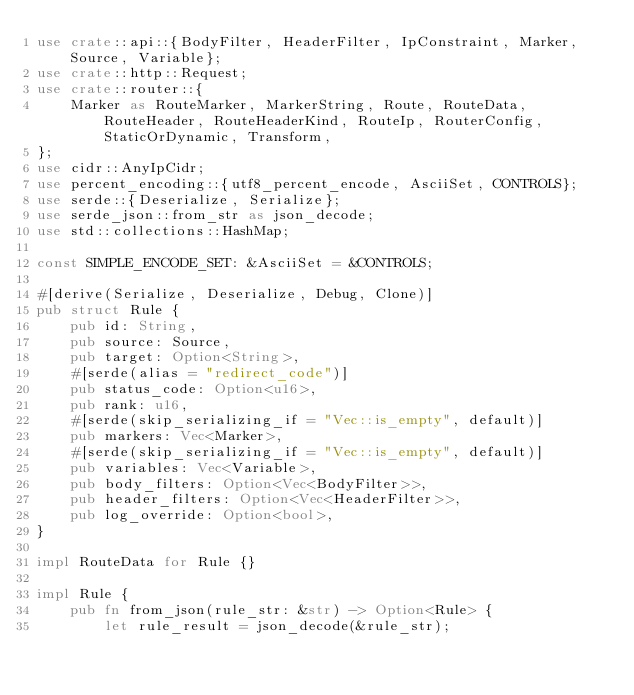<code> <loc_0><loc_0><loc_500><loc_500><_Rust_>use crate::api::{BodyFilter, HeaderFilter, IpConstraint, Marker, Source, Variable};
use crate::http::Request;
use crate::router::{
    Marker as RouteMarker, MarkerString, Route, RouteData, RouteHeader, RouteHeaderKind, RouteIp, RouterConfig, StaticOrDynamic, Transform,
};
use cidr::AnyIpCidr;
use percent_encoding::{utf8_percent_encode, AsciiSet, CONTROLS};
use serde::{Deserialize, Serialize};
use serde_json::from_str as json_decode;
use std::collections::HashMap;

const SIMPLE_ENCODE_SET: &AsciiSet = &CONTROLS;

#[derive(Serialize, Deserialize, Debug, Clone)]
pub struct Rule {
    pub id: String,
    pub source: Source,
    pub target: Option<String>,
    #[serde(alias = "redirect_code")]
    pub status_code: Option<u16>,
    pub rank: u16,
    #[serde(skip_serializing_if = "Vec::is_empty", default)]
    pub markers: Vec<Marker>,
    #[serde(skip_serializing_if = "Vec::is_empty", default)]
    pub variables: Vec<Variable>,
    pub body_filters: Option<Vec<BodyFilter>>,
    pub header_filters: Option<Vec<HeaderFilter>>,
    pub log_override: Option<bool>,
}

impl RouteData for Rule {}

impl Rule {
    pub fn from_json(rule_str: &str) -> Option<Rule> {
        let rule_result = json_decode(&rule_str);
</code> 